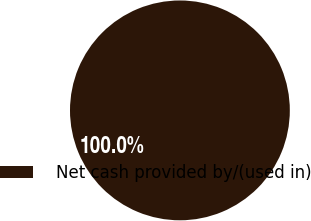<chart> <loc_0><loc_0><loc_500><loc_500><pie_chart><fcel>Net cash provided by/(used in)<nl><fcel>100.0%<nl></chart> 